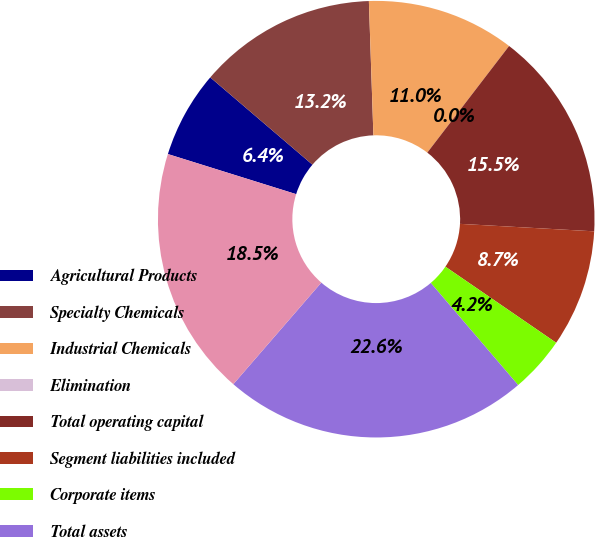Convert chart to OTSL. <chart><loc_0><loc_0><loc_500><loc_500><pie_chart><fcel>Agricultural Products<fcel>Specialty Chemicals<fcel>Industrial Chemicals<fcel>Elimination<fcel>Total operating capital<fcel>Segment liabilities included<fcel>Corporate items<fcel>Total assets<fcel>Total segment assets<nl><fcel>6.43%<fcel>13.21%<fcel>10.95%<fcel>0.0%<fcel>15.47%<fcel>8.69%<fcel>4.16%<fcel>22.62%<fcel>18.46%<nl></chart> 